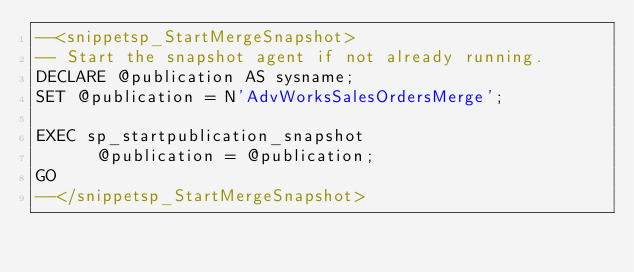Convert code to text. <code><loc_0><loc_0><loc_500><loc_500><_SQL_>--<snippetsp_StartMergeSnapshot>
-- Start the snapshot agent if not already running.
DECLARE @publication AS sysname;
SET @publication = N'AdvWorksSalesOrdersMerge';

EXEC sp_startpublication_snapshot
      @publication = @publication;
GO
--</snippetsp_StartMergeSnapshot></code> 